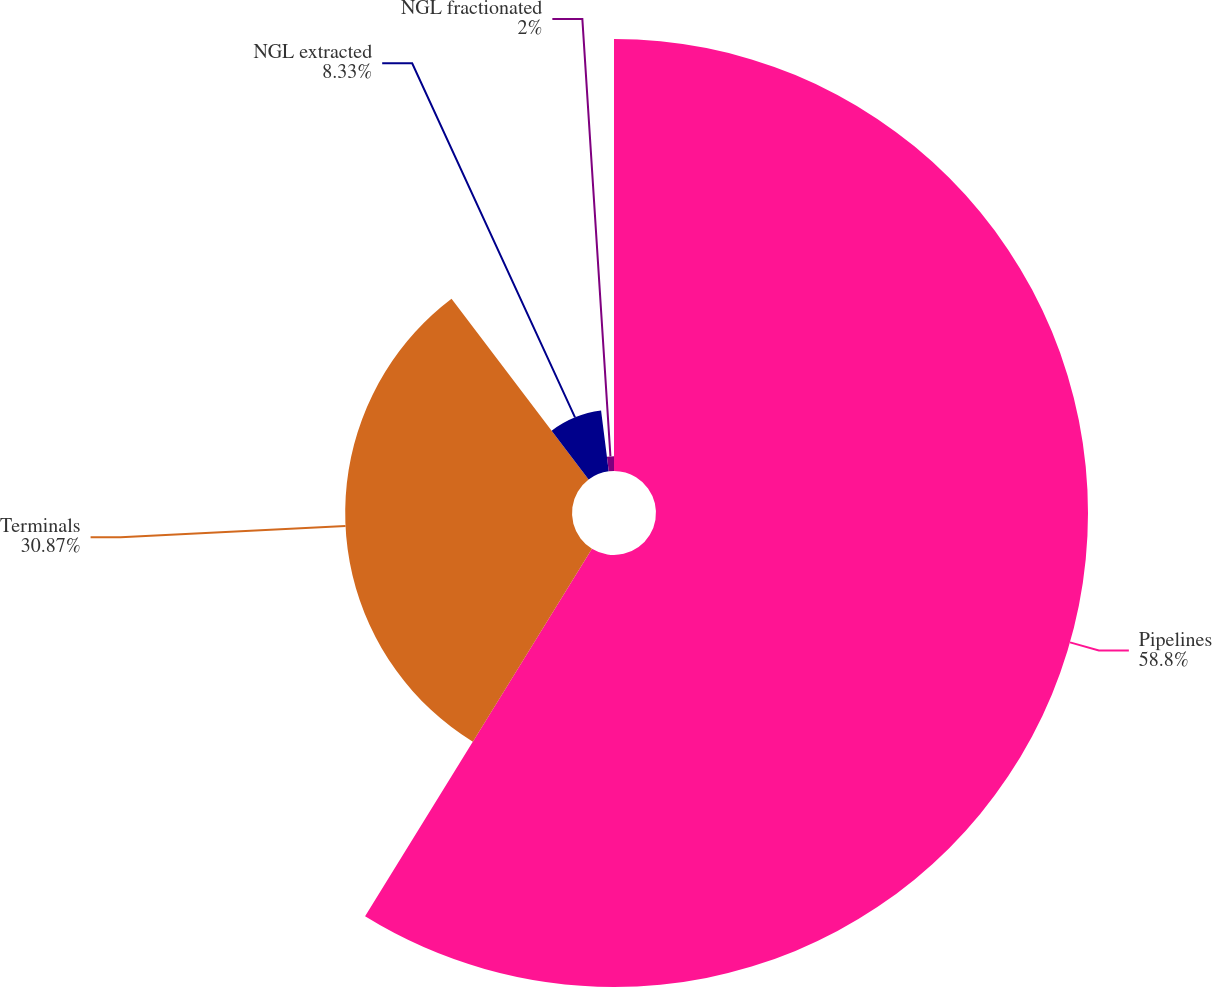Convert chart to OTSL. <chart><loc_0><loc_0><loc_500><loc_500><pie_chart><fcel>Pipelines<fcel>Terminals<fcel>NGL extracted<fcel>NGL fractionated<nl><fcel>58.8%<fcel>30.87%<fcel>8.33%<fcel>2.0%<nl></chart> 